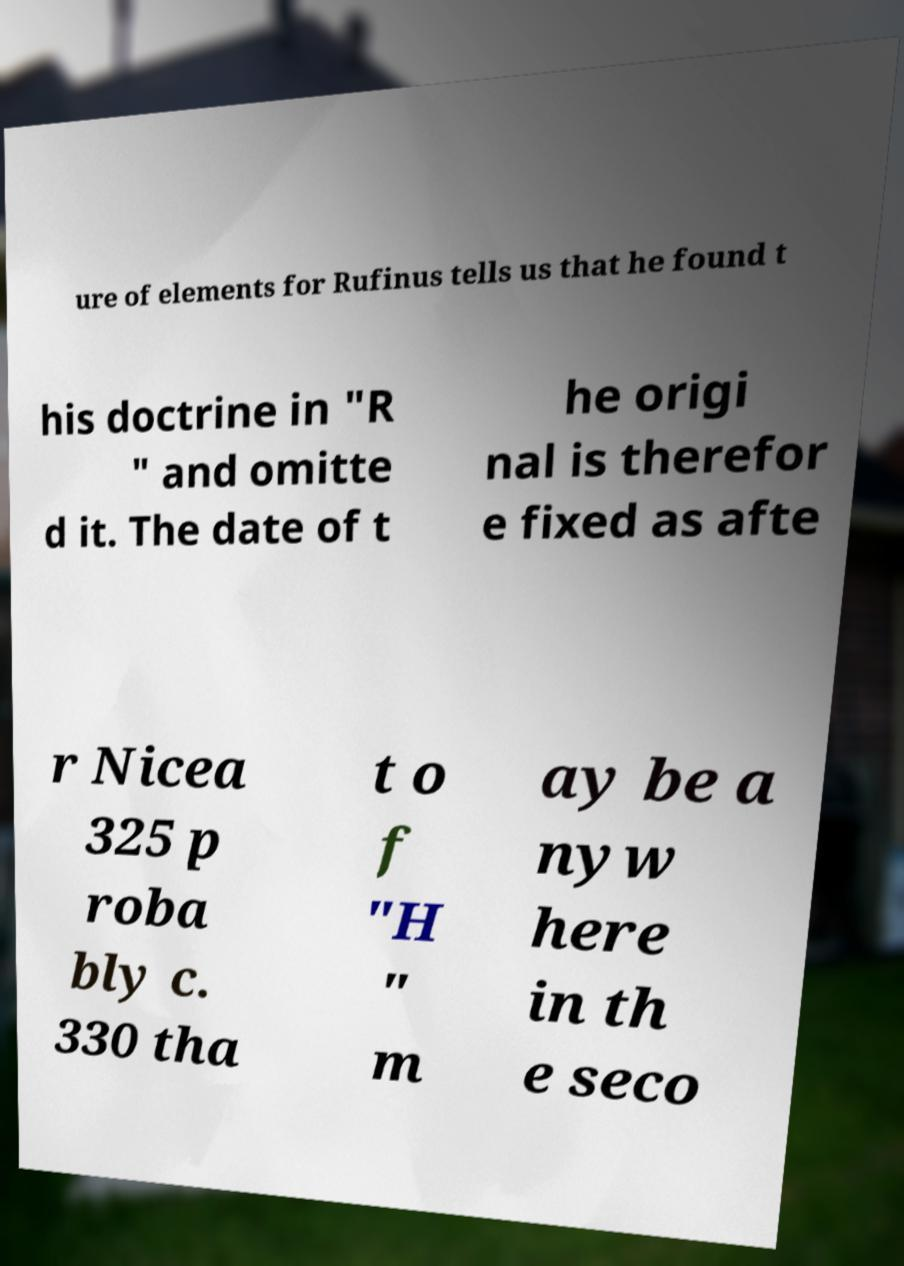Could you assist in decoding the text presented in this image and type it out clearly? ure of elements for Rufinus tells us that he found t his doctrine in "R " and omitte d it. The date of t he origi nal is therefor e fixed as afte r Nicea 325 p roba bly c. 330 tha t o f "H " m ay be a nyw here in th e seco 